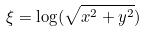Convert formula to latex. <formula><loc_0><loc_0><loc_500><loc_500>\xi = \log ( \sqrt { x ^ { 2 } + y ^ { 2 } } )</formula> 